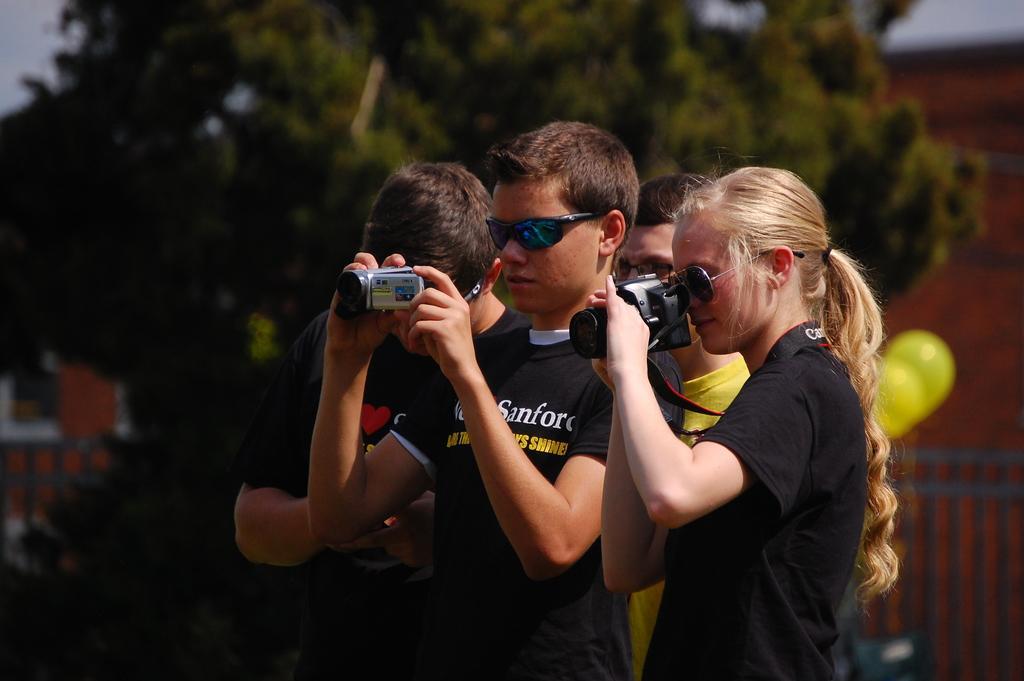Please provide a concise description of this image. In this image I can see a group of people are holding a camera in their hands. 